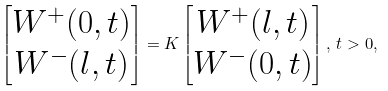Convert formula to latex. <formula><loc_0><loc_0><loc_500><loc_500>\begin{bmatrix} W ^ { + } ( 0 , t ) \\ W ^ { - } ( l , t ) \end{bmatrix} = K \begin{bmatrix} W ^ { + } ( l , t ) \\ W ^ { - } ( 0 , t ) \end{bmatrix} , \, t > 0 ,</formula> 